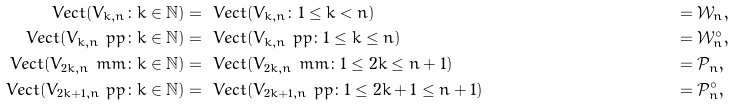<formula> <loc_0><loc_0><loc_500><loc_500>\ V e c t ( V _ { k , n } \colon k \in \mathbb { N } ) & = \ V e c t ( V _ { k , n } \colon 1 \leq k < n ) & & = \mathcal { W } _ { n } , \\ \ V e c t ( V _ { k , n } \ p p \colon k \in \mathbb { N } ) & = \ V e c t ( V _ { k , n } \ p p \colon 1 \leq k \leq n ) & & = \mathcal { W } _ { n } ^ { \circ } , \\ \ V e c t ( V _ { 2 k , n } \ m m \colon k \in \mathbb { N } ) & = \ V e c t ( V _ { 2 k , n } \ m m \colon 1 \leq 2 k \leq n + 1 ) & & = \mathcal { P } _ { n } , \\ \ V e c t ( V _ { 2 k + 1 , n } \ p p \colon k \in \mathbb { N } ) & = \ V e c t ( V _ { 2 k + 1 , n } \ p p \colon 1 \leq 2 k + 1 \leq n + 1 ) & & = \mathcal { P } _ { n } ^ { \circ } ,</formula> 